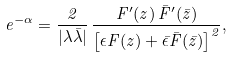<formula> <loc_0><loc_0><loc_500><loc_500>e ^ { - \alpha } = \frac { 2 } { | \lambda \bar { \lambda } | } \, \frac { F ^ { \prime } ( z ) \, \bar { F } ^ { \prime } ( \bar { z } ) } { \left [ \epsilon F ( z ) + \bar { \epsilon } \bar { F } ( \bar { z } ) \right ] ^ { 2 } } ,</formula> 